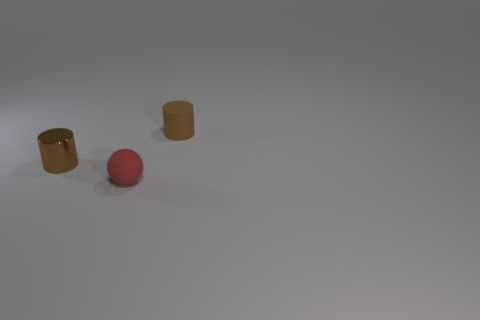What number of objects are rubber blocks or small brown objects that are left of the small brown matte object?
Your answer should be compact. 1. Is there a metal thing that is right of the small rubber object behind the red matte ball?
Your response must be concise. No. What color is the cylinder that is on the right side of the tiny red rubber sphere?
Give a very brief answer. Brown. Are there an equal number of small red matte objects that are on the left side of the tiny matte ball and big red matte cubes?
Offer a terse response. Yes. There is a object that is on the left side of the brown matte cylinder and on the right side of the brown shiny cylinder; what is its shape?
Provide a succinct answer. Sphere. The other thing that is the same shape as the small brown rubber object is what color?
Give a very brief answer. Brown. Is there any other thing that has the same color as the small sphere?
Provide a succinct answer. No. What shape is the tiny rubber thing that is in front of the brown thing in front of the brown thing right of the brown shiny object?
Make the answer very short. Sphere. There is a brown metal object in front of the small brown rubber thing; is its size the same as the matte cylinder that is behind the tiny matte ball?
Make the answer very short. Yes. How many brown cylinders have the same material as the small sphere?
Offer a terse response. 1. 